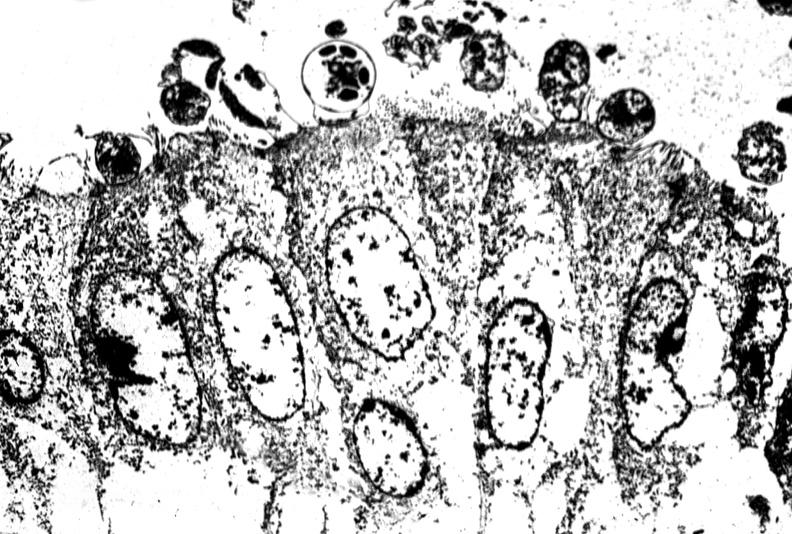s breast present?
Answer the question using a single word or phrase. No 